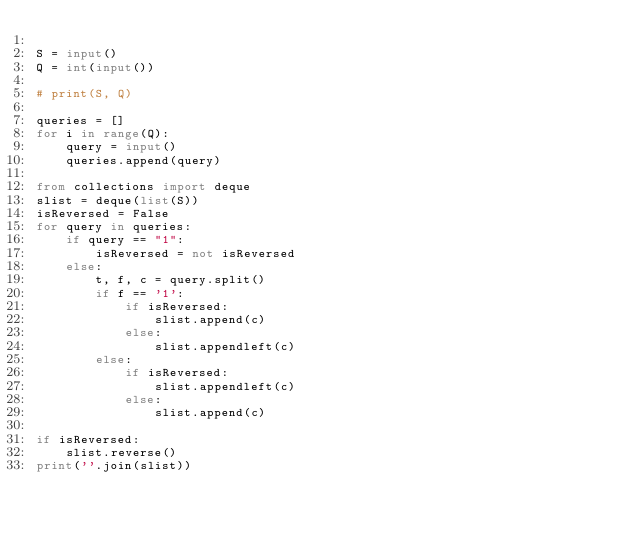Convert code to text. <code><loc_0><loc_0><loc_500><loc_500><_Python_>
S = input()
Q = int(input())

# print(S, Q)

queries = []
for i in range(Q):
    query = input()
    queries.append(query)

from collections import deque
slist = deque(list(S))
isReversed = False
for query in queries:
    if query == "1":
        isReversed = not isReversed
    else:
        t, f, c = query.split()
        if f == '1':
            if isReversed:
                slist.append(c)
            else:
                slist.appendleft(c)
        else:
            if isReversed:
                slist.appendleft(c)
            else:
                slist.append(c)

if isReversed:
    slist.reverse()
print(''.join(slist))
</code> 